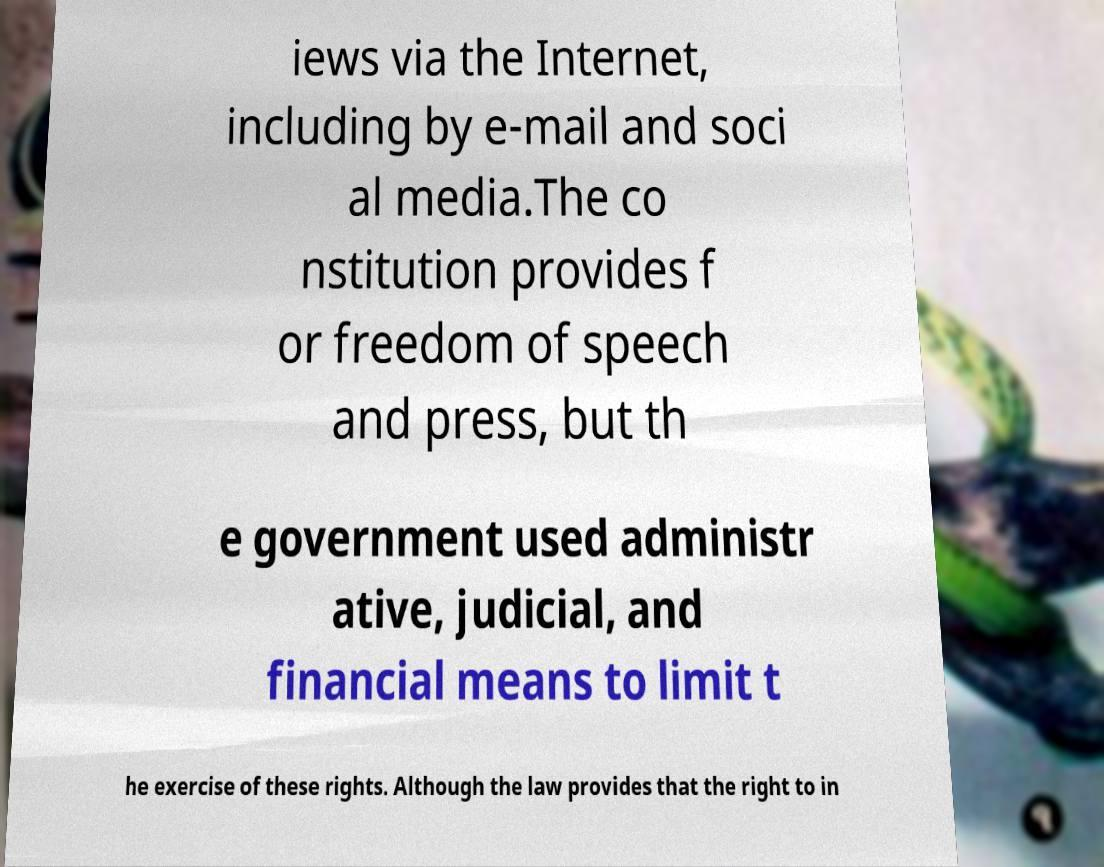What messages or text are displayed in this image? I need them in a readable, typed format. iews via the Internet, including by e-mail and soci al media.The co nstitution provides f or freedom of speech and press, but th e government used administr ative, judicial, and financial means to limit t he exercise of these rights. Although the law provides that the right to in 